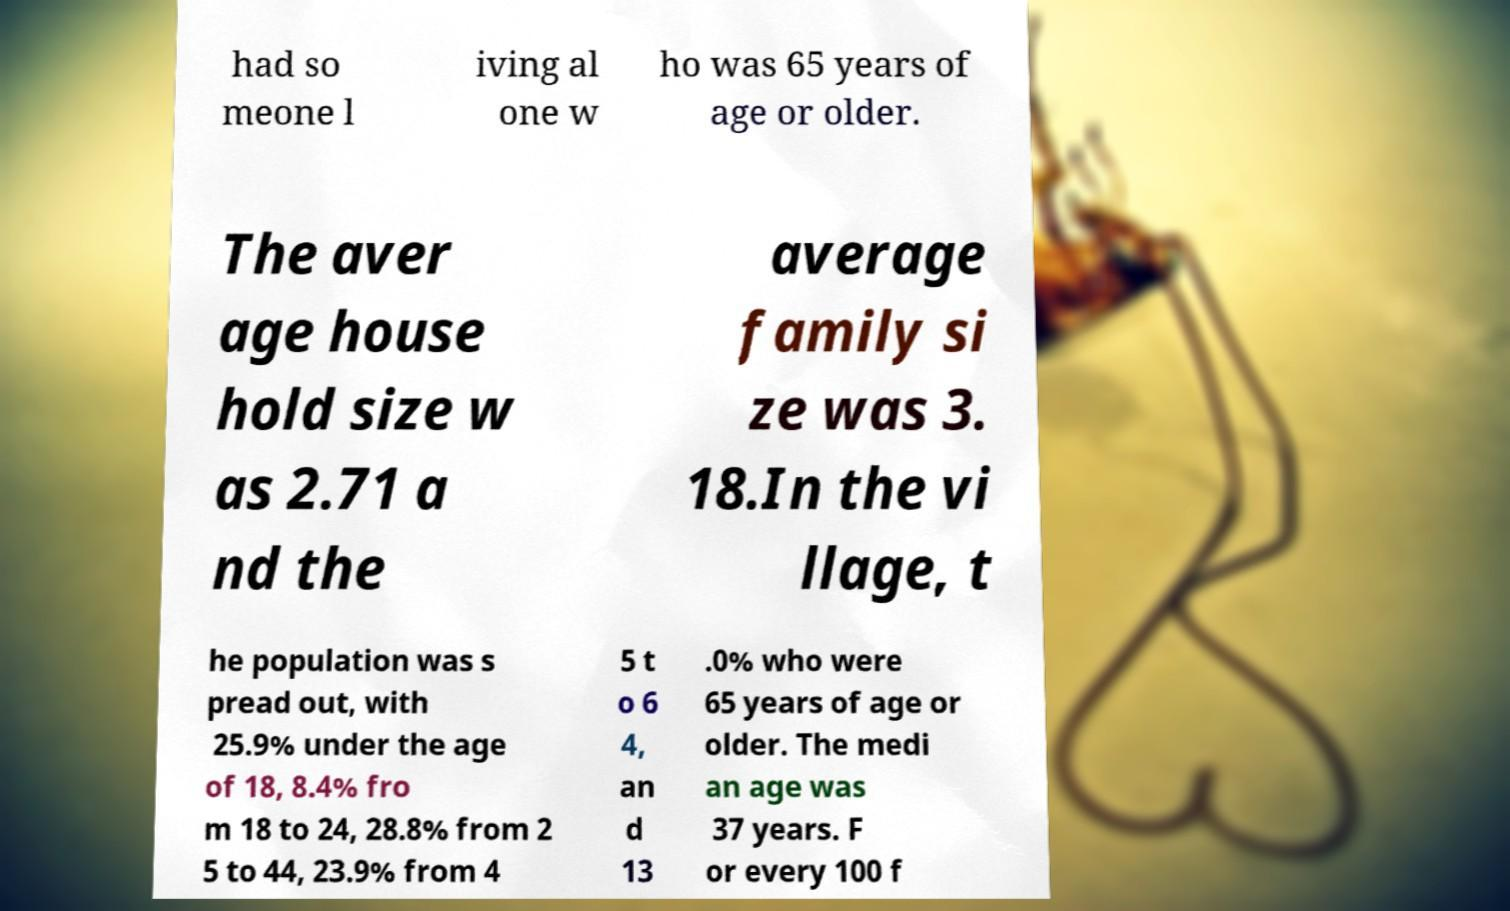Can you read and provide the text displayed in the image?This photo seems to have some interesting text. Can you extract and type it out for me? had so meone l iving al one w ho was 65 years of age or older. The aver age house hold size w as 2.71 a nd the average family si ze was 3. 18.In the vi llage, t he population was s pread out, with 25.9% under the age of 18, 8.4% fro m 18 to 24, 28.8% from 2 5 to 44, 23.9% from 4 5 t o 6 4, an d 13 .0% who were 65 years of age or older. The medi an age was 37 years. F or every 100 f 